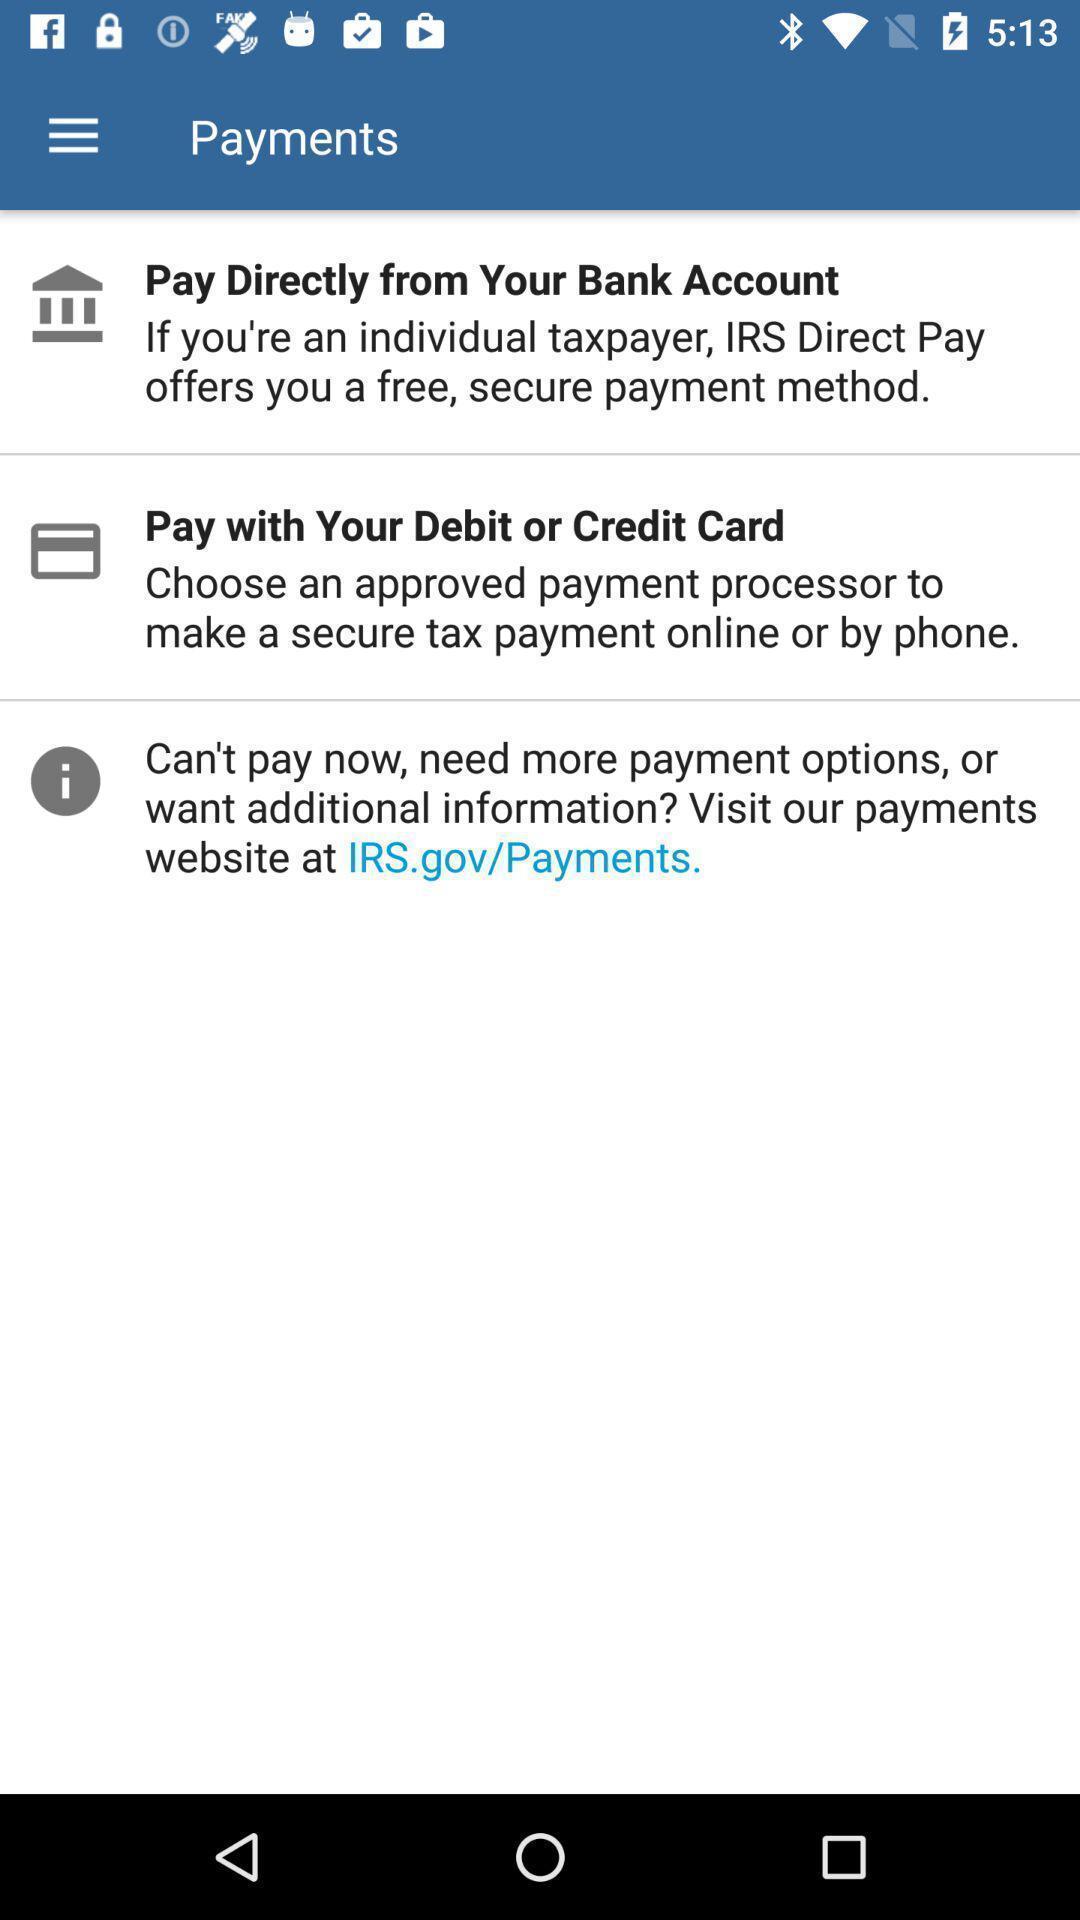Provide a textual representation of this image. Screen shows payment options in a financial app. 